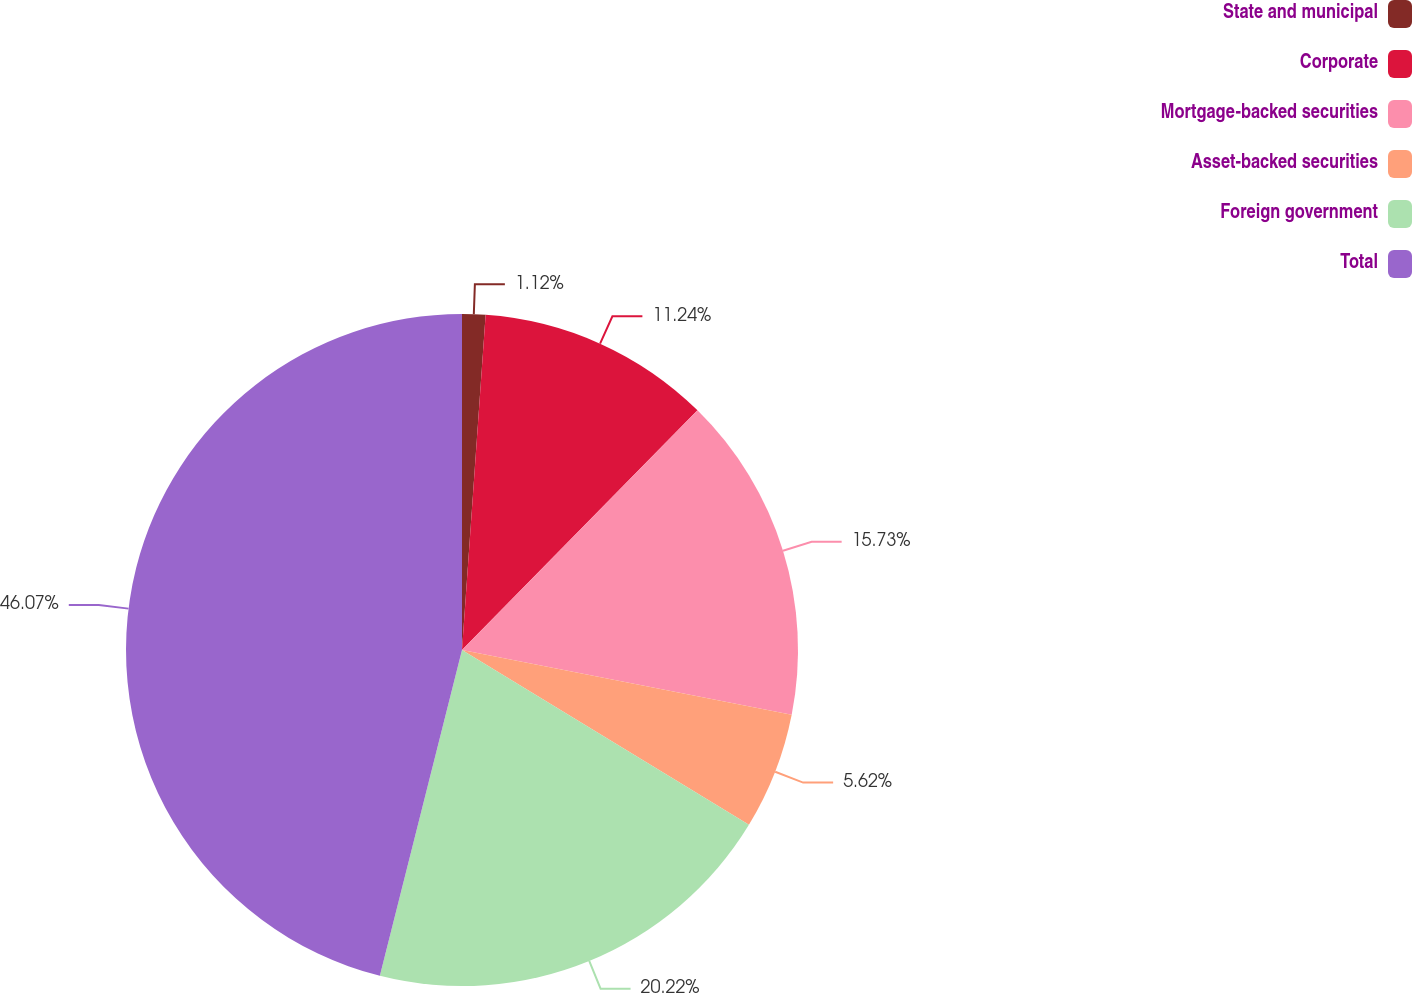Convert chart to OTSL. <chart><loc_0><loc_0><loc_500><loc_500><pie_chart><fcel>State and municipal<fcel>Corporate<fcel>Mortgage-backed securities<fcel>Asset-backed securities<fcel>Foreign government<fcel>Total<nl><fcel>1.12%<fcel>11.24%<fcel>15.73%<fcel>5.62%<fcel>20.22%<fcel>46.07%<nl></chart> 